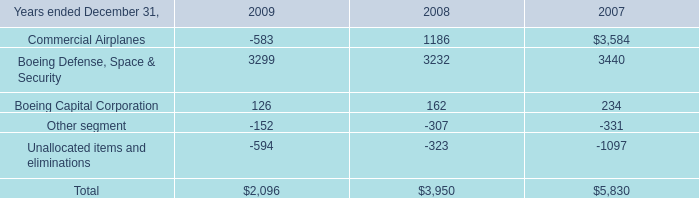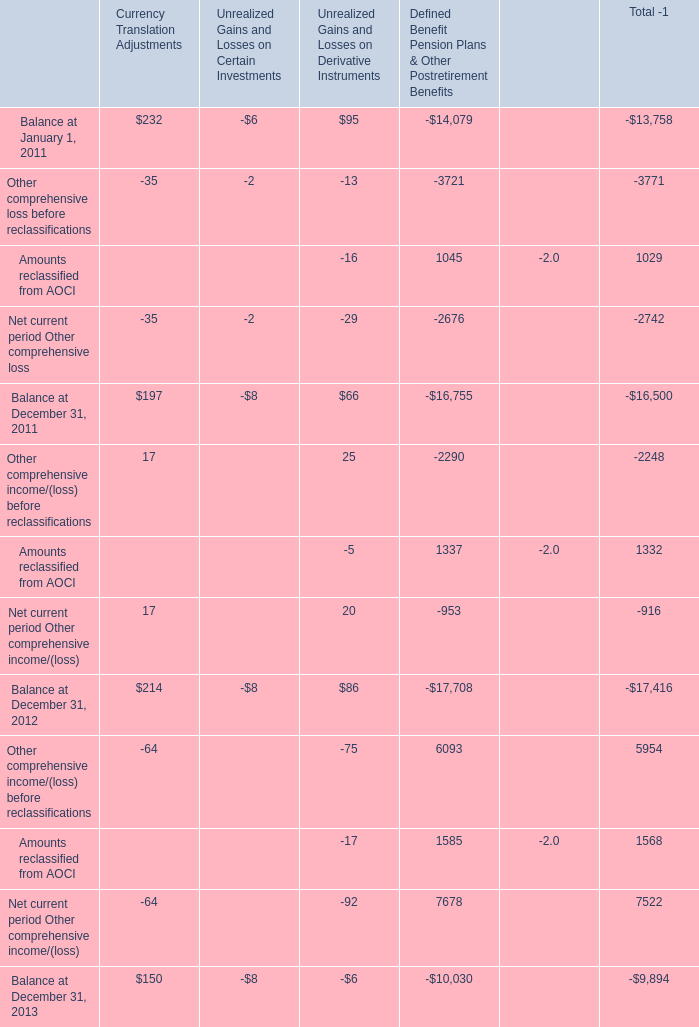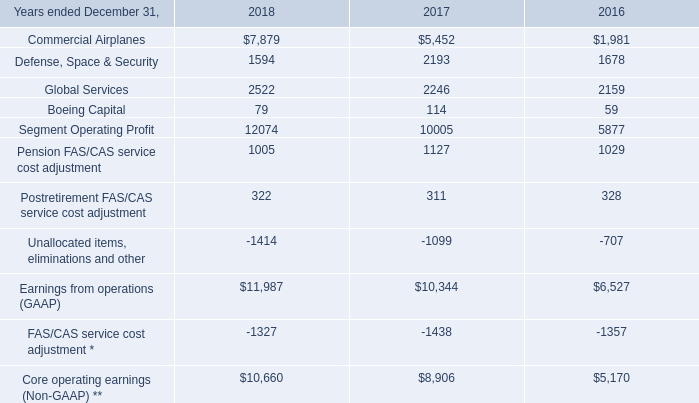Which year the Currency Translation Adjustments is the highest? 
Answer: 2012. 